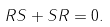<formula> <loc_0><loc_0><loc_500><loc_500>R S + S R = 0 .</formula> 